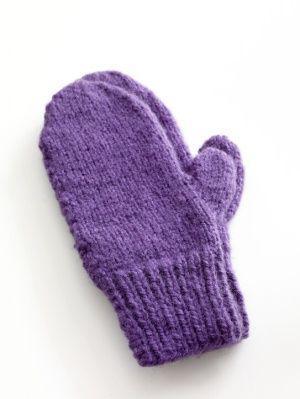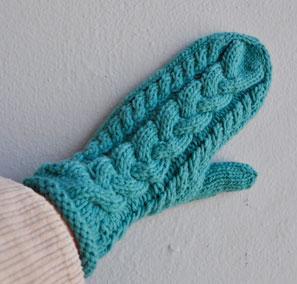The first image is the image on the left, the second image is the image on the right. Examine the images to the left and right. Is the description "The mittens in the left image are on a pair of human hands." accurate? Answer yes or no. No. The first image is the image on the left, the second image is the image on the right. Examine the images to the left and right. Is the description "One pair of mittens features at least two or more colors in a patterned design." accurate? Answer yes or no. No. 